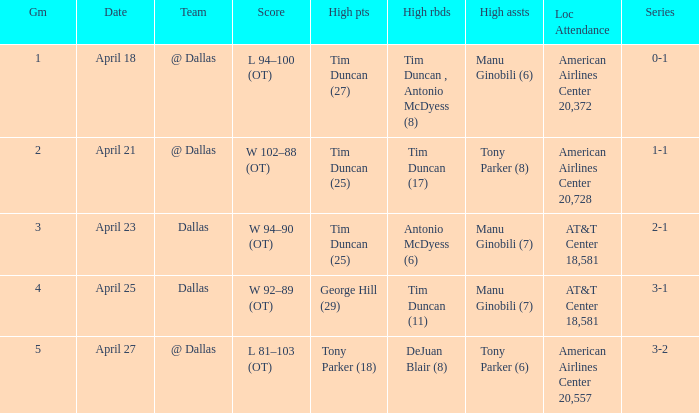When 1-1 is the series who is the team? @ Dallas. 